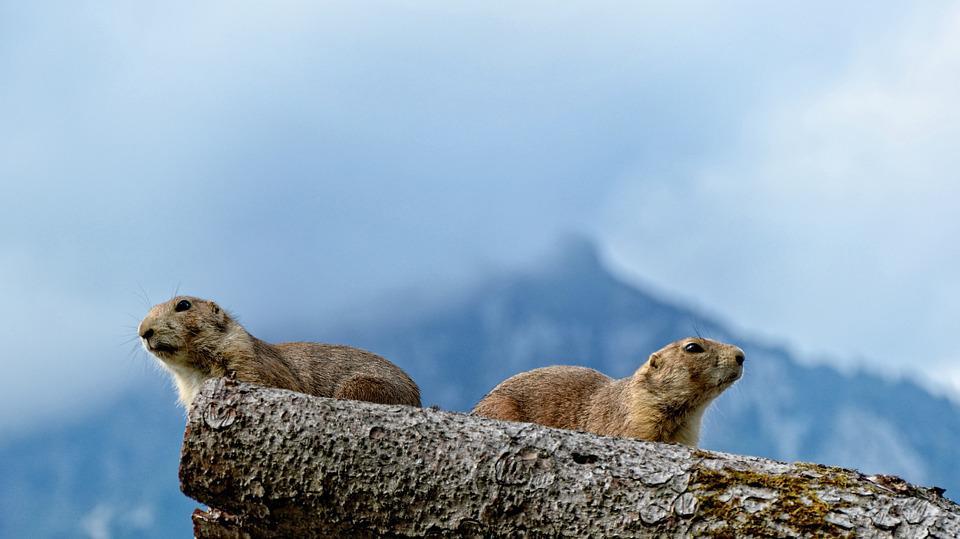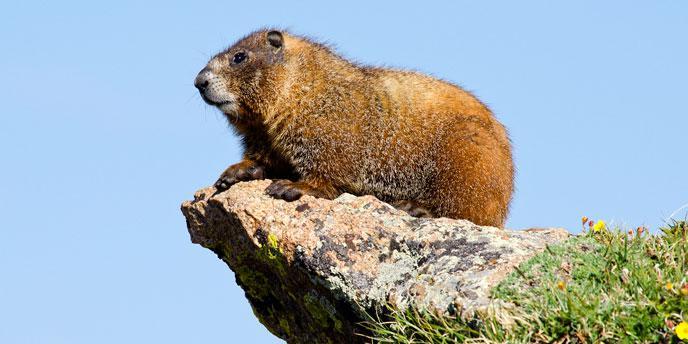The first image is the image on the left, the second image is the image on the right. Examine the images to the left and right. Is the description "There is at least one animal lying on its belly and facing left in the image on the left." accurate? Answer yes or no. Yes. 